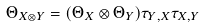<formula> <loc_0><loc_0><loc_500><loc_500>\Theta _ { X \otimes Y } = ( \Theta _ { X } \otimes \Theta _ { Y } ) \tau _ { Y , X } \tau _ { X , Y }</formula> 